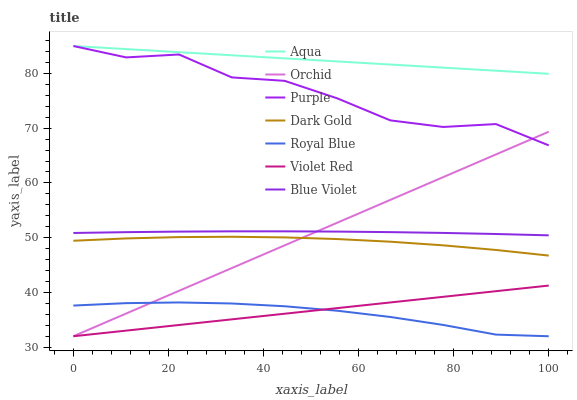Does Royal Blue have the minimum area under the curve?
Answer yes or no. Yes. Does Aqua have the maximum area under the curve?
Answer yes or no. Yes. Does Dark Gold have the minimum area under the curve?
Answer yes or no. No. Does Dark Gold have the maximum area under the curve?
Answer yes or no. No. Is Violet Red the smoothest?
Answer yes or no. Yes. Is Purple the roughest?
Answer yes or no. Yes. Is Dark Gold the smoothest?
Answer yes or no. No. Is Dark Gold the roughest?
Answer yes or no. No. Does Violet Red have the lowest value?
Answer yes or no. Yes. Does Dark Gold have the lowest value?
Answer yes or no. No. Does Aqua have the highest value?
Answer yes or no. Yes. Does Dark Gold have the highest value?
Answer yes or no. No. Is Royal Blue less than Purple?
Answer yes or no. Yes. Is Blue Violet greater than Dark Gold?
Answer yes or no. Yes. Does Dark Gold intersect Orchid?
Answer yes or no. Yes. Is Dark Gold less than Orchid?
Answer yes or no. No. Is Dark Gold greater than Orchid?
Answer yes or no. No. Does Royal Blue intersect Purple?
Answer yes or no. No. 